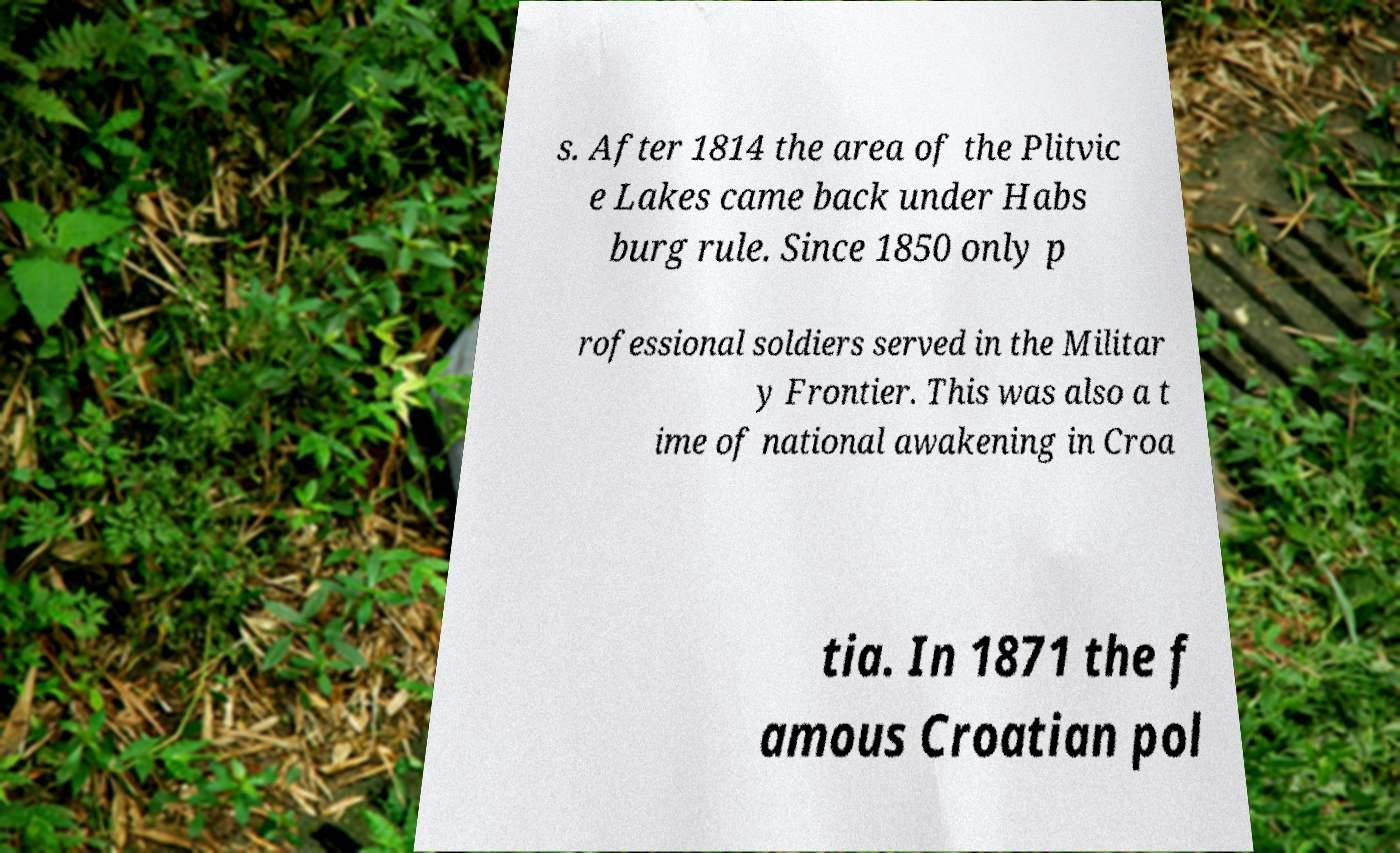I need the written content from this picture converted into text. Can you do that? s. After 1814 the area of the Plitvic e Lakes came back under Habs burg rule. Since 1850 only p rofessional soldiers served in the Militar y Frontier. This was also a t ime of national awakening in Croa tia. In 1871 the f amous Croatian pol 